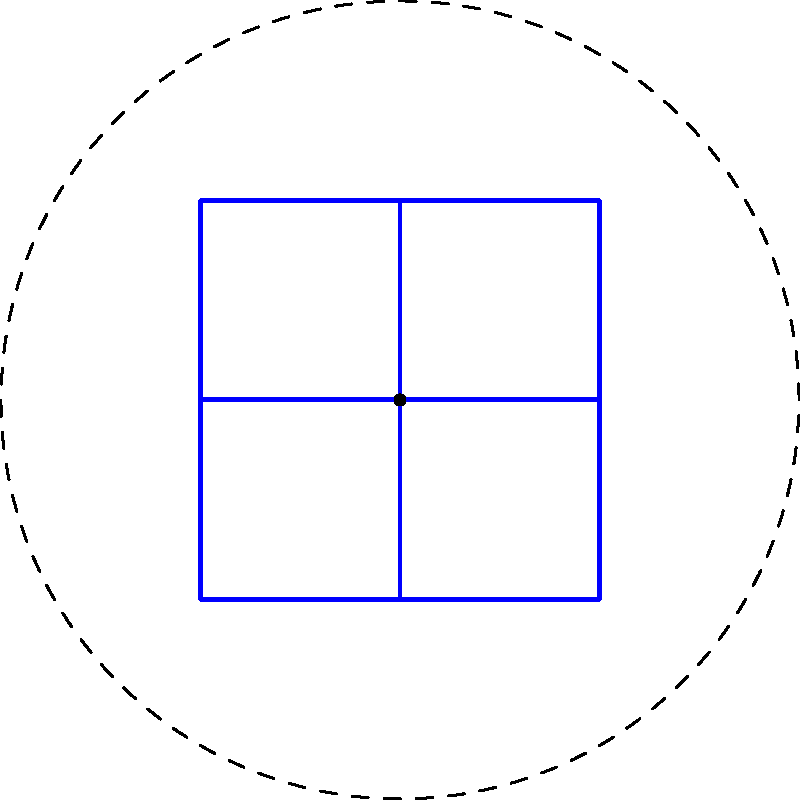A traditional Celtic knot pattern found on an ancient artifact from Ardboe exhibits rotational symmetry. How many degrees must the pattern be rotated to achieve congruence with its original position? To determine the rotational symmetry of this Celtic knot pattern, we need to follow these steps:

1. Observe the pattern carefully. It consists of four identical sections arranged around a central point.

2. Identify the smallest rotation that brings the pattern back to its original position. In this case, a 90-degree rotation will align the pattern with itself.

3. To confirm, we can rotate the pattern by 90 degrees, 180 degrees, 270 degrees, and 360 degrees:
   - 90 degrees: The pattern aligns with itself
   - 180 degrees: The pattern aligns with itself
   - 270 degrees: The pattern aligns with itself
   - 360 degrees: The pattern returns to its original position

4. The smallest non-zero rotation that brings the pattern back to its original position is 90 degrees.

5. We can express this mathematically as:
   $360^\circ \div 4 = 90^\circ$

   Where 4 represents the number of times the pattern repeats in a full rotation.

Therefore, the pattern must be rotated 90 degrees to achieve congruence with its original position.
Answer: $90^\circ$ 